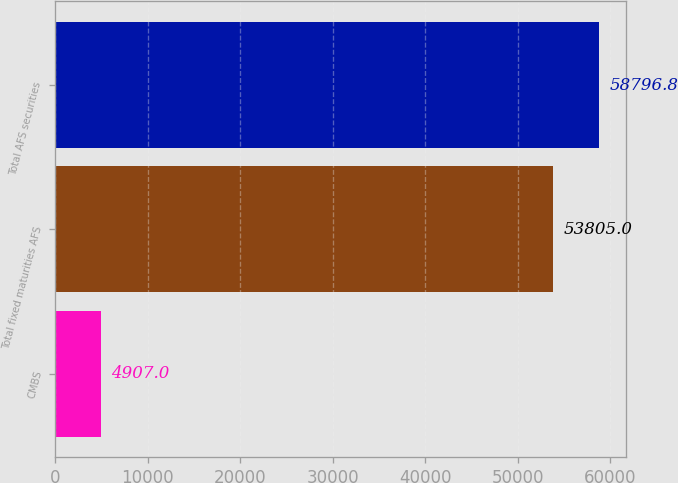Convert chart to OTSL. <chart><loc_0><loc_0><loc_500><loc_500><bar_chart><fcel>CMBS<fcel>Total fixed maturities AFS<fcel>Total AFS securities<nl><fcel>4907<fcel>53805<fcel>58796.8<nl></chart> 